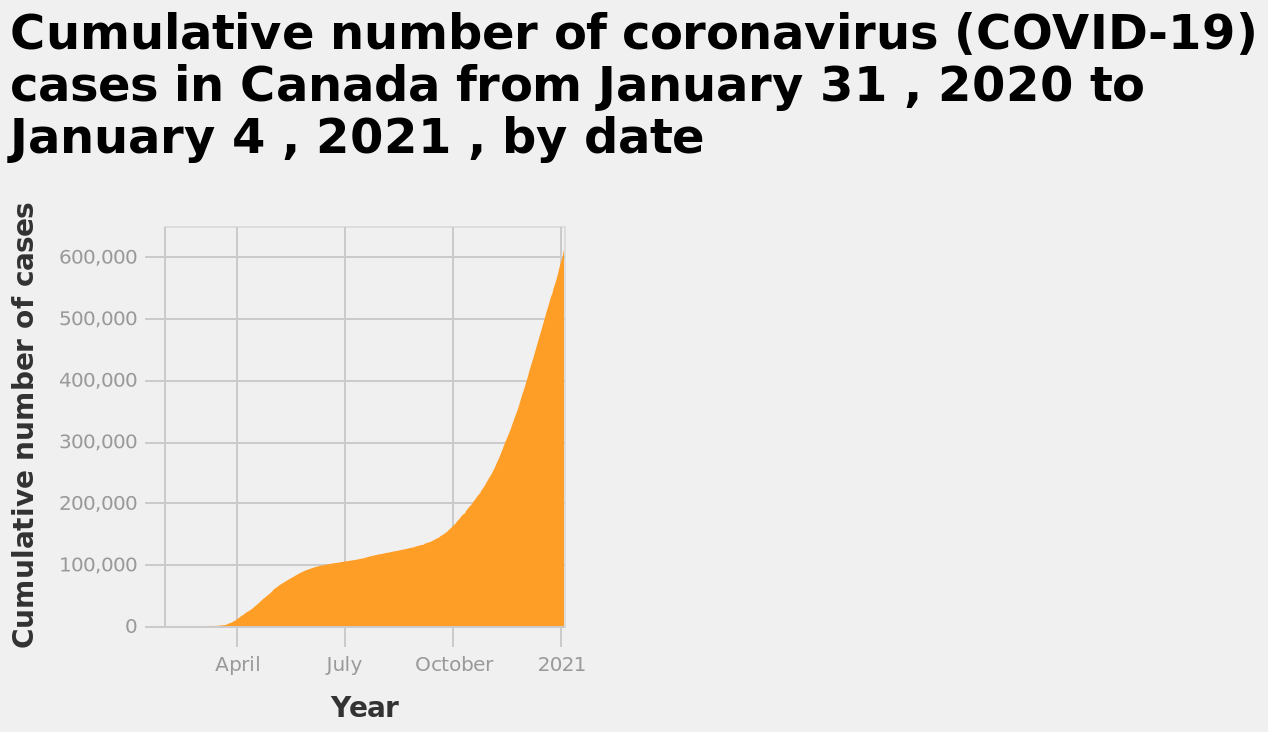<image>
What does the y-axis represent in the area diagram?  The y-axis represents the cumulative number of COVID-19 cases in Canada on a linear scale ranging from 0 to 600,000. What does the x-axis show in the area diagram? The x-axis shows the year, starting from April and ending with 2021. 